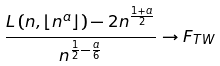Convert formula to latex. <formula><loc_0><loc_0><loc_500><loc_500>\frac { L \left ( n , \lfloor n ^ { a } \rfloor \right ) - 2 n ^ { \frac { 1 + a } { 2 } } } { n ^ { \frac { 1 } { 2 } - \frac { a } { 6 } } } \to F _ { T W }</formula> 